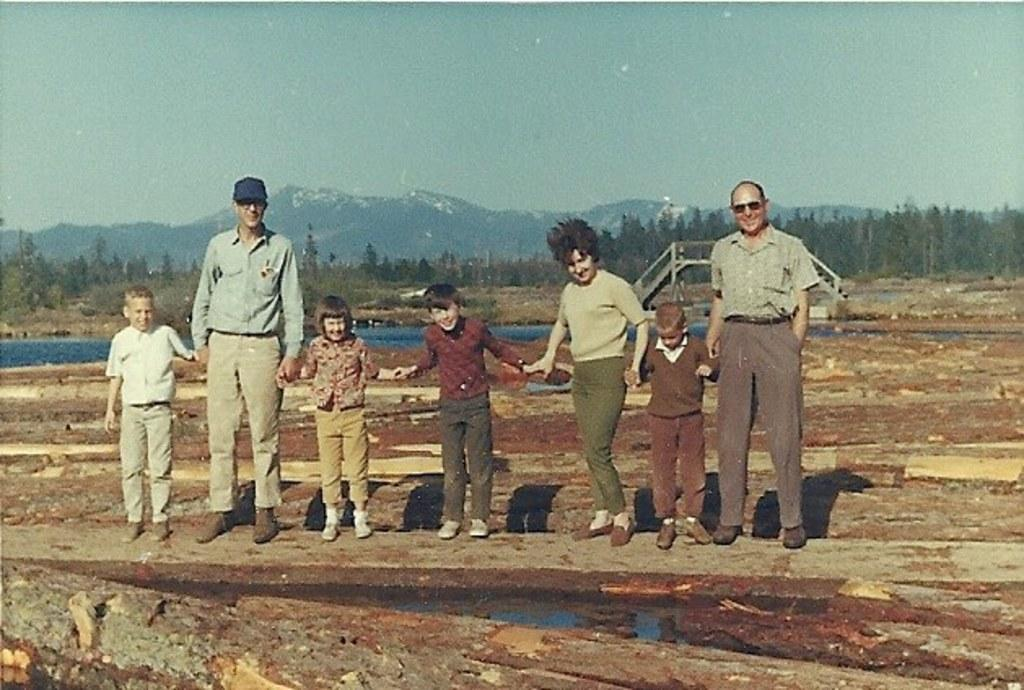What are the people in the image doing? The people in the image are standing on the ground holding their hands. What body of water can be seen in the image? There is a lake in the image. What structure is present in the image that connects two areas? There is a bridge in the image. What type of vegetation is visible in the image? There are trees in the image. What type of landform can be seen in the image? There are hills in the image. What is visible in the sky in the image? The sky is visible in the image. What type of ornament is hanging from the trees in the image? There are no ornaments hanging from the trees in the image; only trees are present. What type of linen is draped over the hills in the image? There is no linen draped over the hills in the image; only hills are present. 